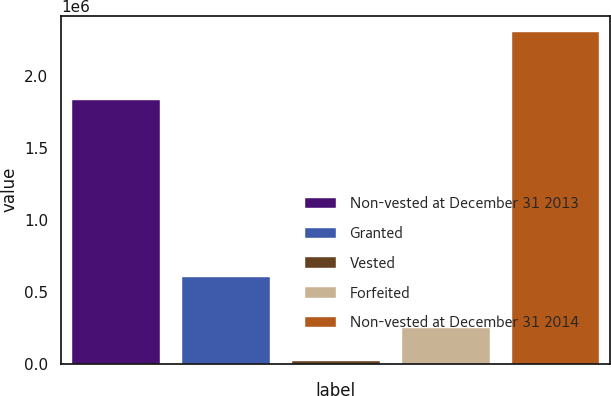<chart> <loc_0><loc_0><loc_500><loc_500><bar_chart><fcel>Non-vested at December 31 2013<fcel>Granted<fcel>Vested<fcel>Forfeited<fcel>Non-vested at December 31 2014<nl><fcel>1.83651e+06<fcel>605144<fcel>20000<fcel>248457<fcel>2.30457e+06<nl></chart> 